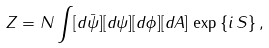<formula> <loc_0><loc_0><loc_500><loc_500>Z = N \int [ d \bar { \psi } ] [ d \psi ] [ d \phi ] [ d A ] \, \exp \, \{ i \, S \} \, ,</formula> 